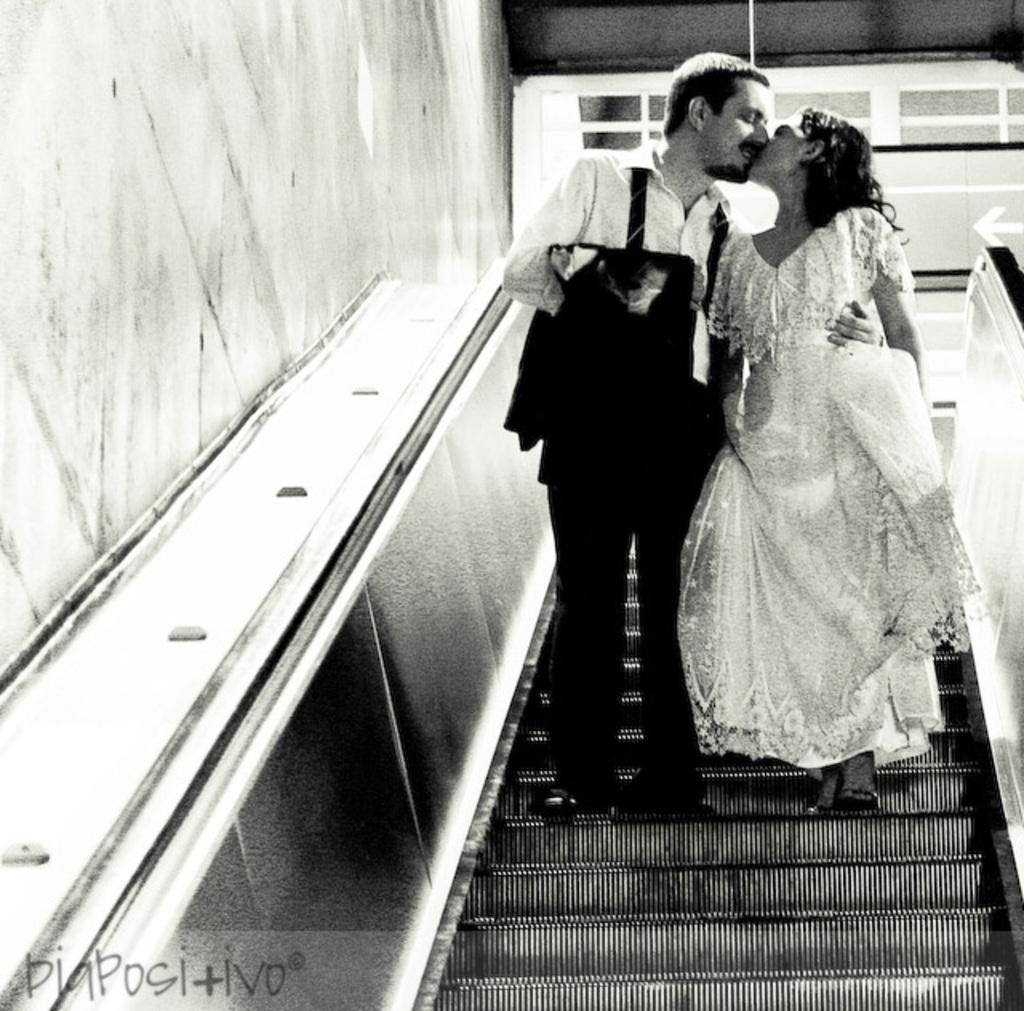In one or two sentences, can you explain what this image depicts? It is a black and white image, on the right side a man and woman are standing on the escalator and kissing each other. 